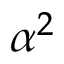<formula> <loc_0><loc_0><loc_500><loc_500>\alpha ^ { 2 }</formula> 